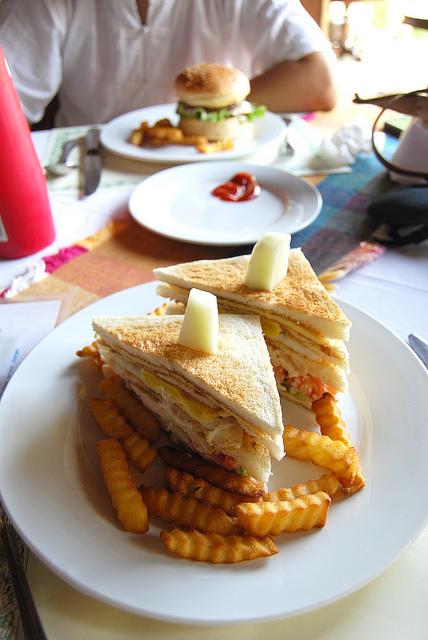How many fries on the plate?
Keep it brief. 11. What is the total number of sandwich skewers?
Keep it brief. 2. Is this meal healthy?
Be succinct. No. What is that sauce on the middle plate?
Keep it brief. Ketchup. 